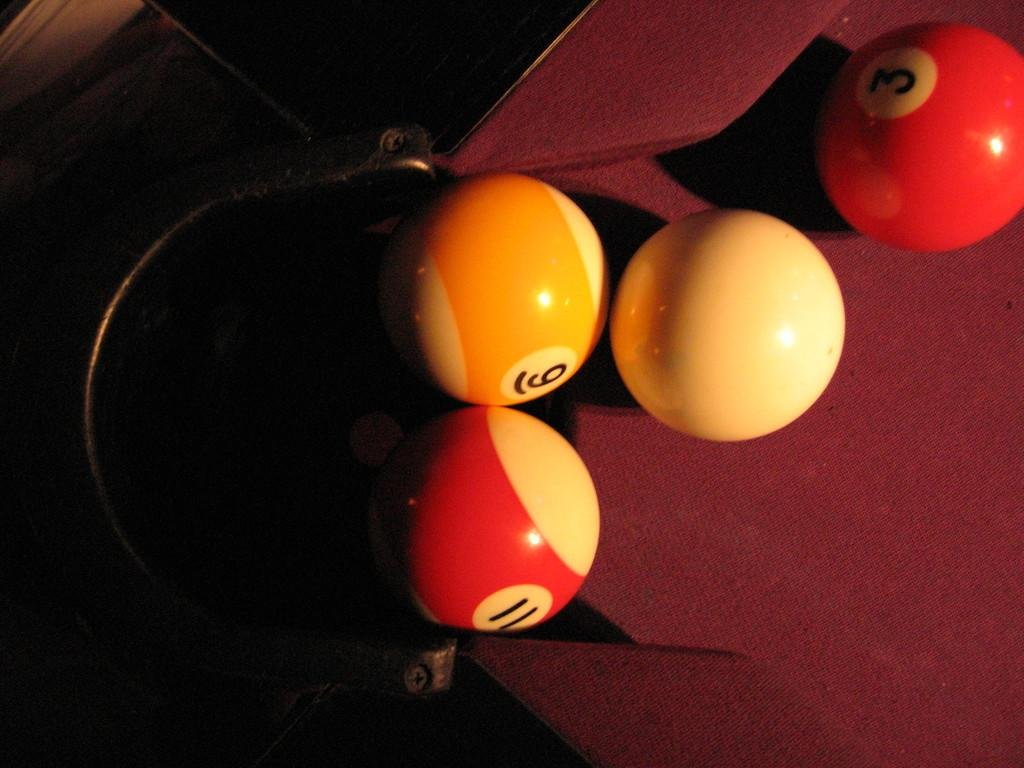Provide a one-sentence caption for the provided image. A pool table with the number eleven, six and three written on them and the white ball. 